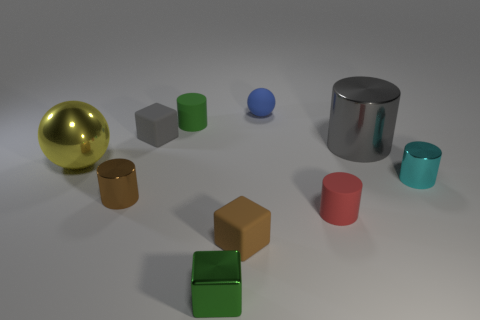Subtract all red cylinders. How many cylinders are left? 4 Subtract all tiny green rubber cylinders. How many cylinders are left? 4 Subtract all blue cylinders. Subtract all yellow spheres. How many cylinders are left? 5 Subtract all spheres. How many objects are left? 8 Subtract all cyan metallic objects. Subtract all green objects. How many objects are left? 7 Add 5 metallic objects. How many metallic objects are left? 10 Add 3 purple rubber things. How many purple rubber things exist? 3 Subtract 0 purple balls. How many objects are left? 10 